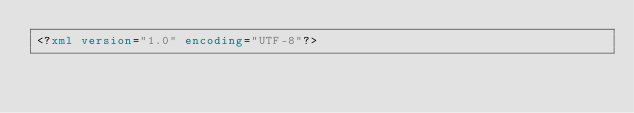Convert code to text. <code><loc_0><loc_0><loc_500><loc_500><_XML_><?xml version="1.0" encoding="UTF-8"?></code> 